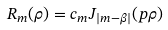Convert formula to latex. <formula><loc_0><loc_0><loc_500><loc_500>R _ { m } ( \rho ) = c _ { m } J _ { | m - \beta | } ( p \rho )</formula> 